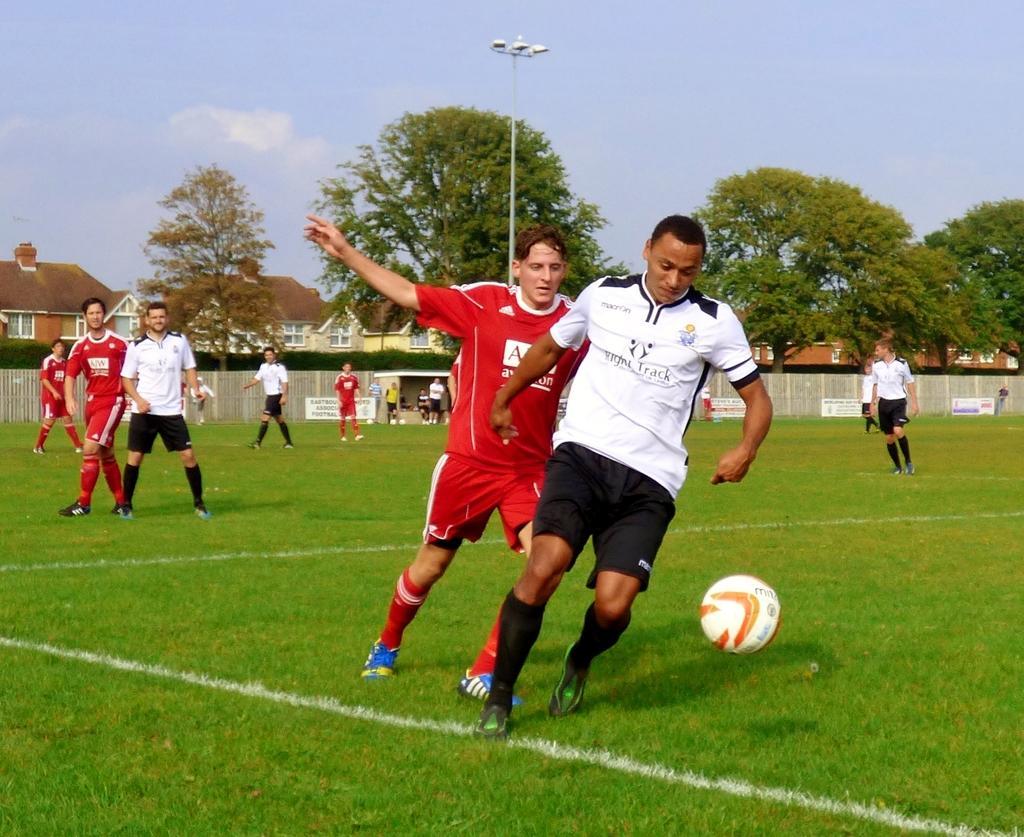Describe this image in one or two sentences. In this image we can see these people wearing red T-shirts and white T-shirts are playing in the ground and here we can see a ball in the air. In the background, we can see the fencehouses, trees, light pole and the sky with clouds. 